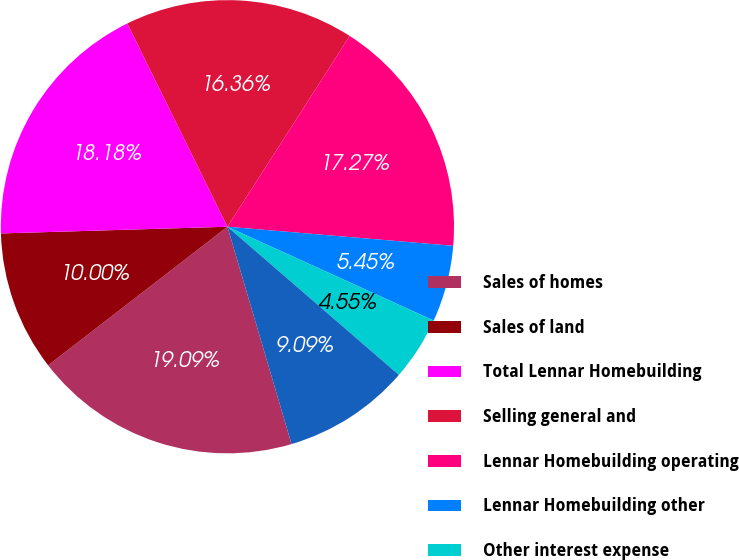Convert chart to OTSL. <chart><loc_0><loc_0><loc_500><loc_500><pie_chart><fcel>Sales of homes<fcel>Sales of land<fcel>Total Lennar Homebuilding<fcel>Selling general and<fcel>Lennar Homebuilding operating<fcel>Lennar Homebuilding other<fcel>Other interest expense<fcel>Lennar Financial Services<nl><fcel>19.09%<fcel>10.0%<fcel>18.18%<fcel>16.36%<fcel>17.27%<fcel>5.45%<fcel>4.55%<fcel>9.09%<nl></chart> 